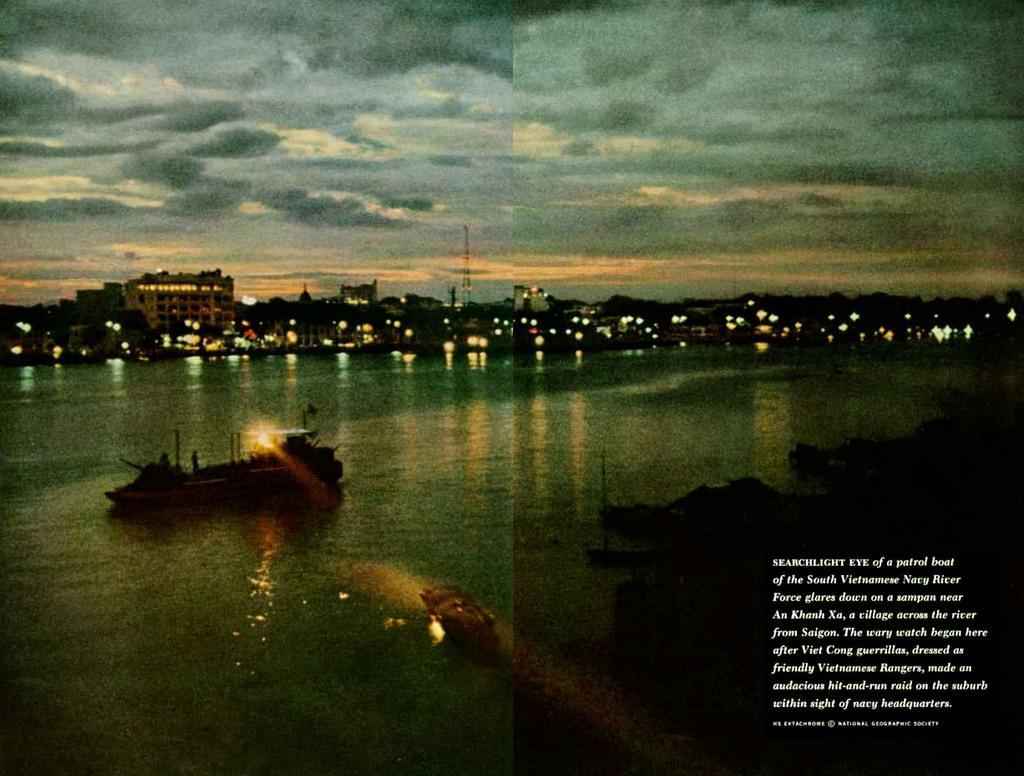How would you summarize this image in a sentence or two? This is an edited picture. In this picture we can see buildings, lights, water and objects. On the right side of the it is dark and we can see text. 